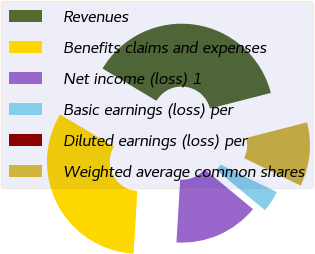<chart> <loc_0><loc_0><loc_500><loc_500><pie_chart><fcel>Revenues<fcel>Benefits claims and expenses<fcel>Net income (loss) 1<fcel>Basic earnings (loss) per<fcel>Diluted earnings (loss) per<fcel>Weighted average common shares<nl><fcel>37.41%<fcel>32.63%<fcel>14.97%<fcel>3.75%<fcel>0.01%<fcel>11.23%<nl></chart> 